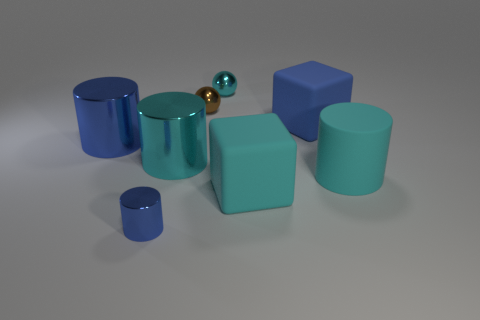Subtract 1 blocks. How many blocks are left? 1 Add 1 tiny brown metal spheres. How many objects exist? 9 Subtract all cyan balls. How many balls are left? 1 Subtract all large cyan metal cylinders. How many cylinders are left? 3 Subtract 2 cyan cylinders. How many objects are left? 6 Subtract all red cubes. Subtract all red spheres. How many cubes are left? 2 Subtract all gray balls. How many blue blocks are left? 1 Subtract all tiny matte cylinders. Subtract all big matte cylinders. How many objects are left? 7 Add 3 small blue cylinders. How many small blue cylinders are left? 4 Add 7 cubes. How many cubes exist? 9 